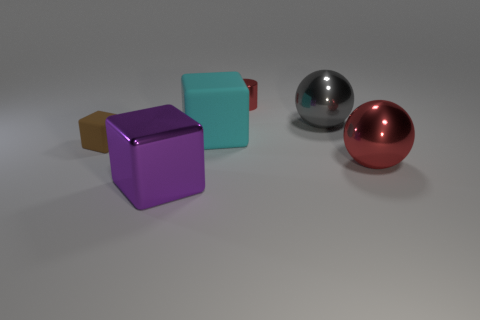What size is the gray shiny ball?
Offer a very short reply. Large. Does the sphere that is in front of the large cyan matte cube have the same size as the metal sphere that is behind the large cyan object?
Offer a terse response. Yes. The other brown object that is the same shape as the big rubber object is what size?
Your response must be concise. Small. Is the size of the cyan rubber object the same as the ball in front of the small block?
Make the answer very short. Yes. Are there any big gray balls behind the large red ball in front of the metal cylinder?
Keep it short and to the point. Yes. What shape is the small object that is right of the purple metallic block?
Your response must be concise. Cylinder. There is a sphere that is the same color as the tiny cylinder; what material is it?
Make the answer very short. Metal. There is a large thing to the right of the large metallic ball that is behind the brown cube; what is its color?
Offer a terse response. Red. Is the size of the red metal cylinder the same as the cyan matte block?
Offer a terse response. No. What is the material of the big cyan object that is the same shape as the brown rubber object?
Your answer should be very brief. Rubber. 